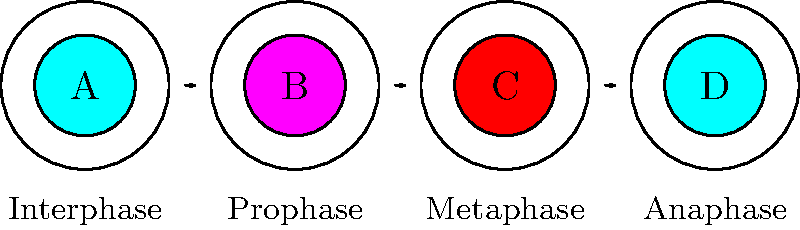As a retired medical doctor with experience in the Arab region, you are asked to review some microscopic images of cell division. Based on the diagram above showing four stages of mitosis, which stage is characterized by the alignment of chromosomes along the cell's equator? To answer this question, let's analyze each stage of mitosis shown in the diagram:

1. Stage A (Interphase): The cell is not actively dividing. The nucleus is intact and the chromatin is dispersed.

2. Stage B (Prophase): The chromosomes begin to condense and become visible. The nuclear envelope starts to break down.

3. Stage C (Metaphase): This is the key stage for our question. The chromosomes are fully condensed and align along the cell's equator, forming the metaphase plate. This alignment is crucial for the equal distribution of genetic material to daughter cells.

4. Stage D (Anaphase): The sister chromatids separate and move towards opposite poles of the cell.

The question asks about the stage where chromosomes align along the cell's equator. This alignment is the defining characteristic of metaphase, which is represented by Stage C in the diagram.
Answer: Metaphase 